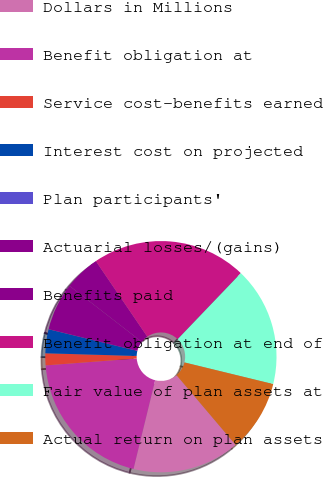<chart> <loc_0><loc_0><loc_500><loc_500><pie_chart><fcel>Dollars in Millions<fcel>Benefit obligation at<fcel>Service cost-benefits earned<fcel>Interest cost on projected<fcel>Plan participants'<fcel>Actuarial losses/(gains)<fcel>Benefits paid<fcel>Benefit obligation at end of<fcel>Fair value of plan assets at<fcel>Actual return on plan assets<nl><fcel>15.0%<fcel>19.99%<fcel>1.67%<fcel>3.34%<fcel>0.01%<fcel>6.67%<fcel>5.0%<fcel>21.66%<fcel>16.66%<fcel>10.0%<nl></chart> 